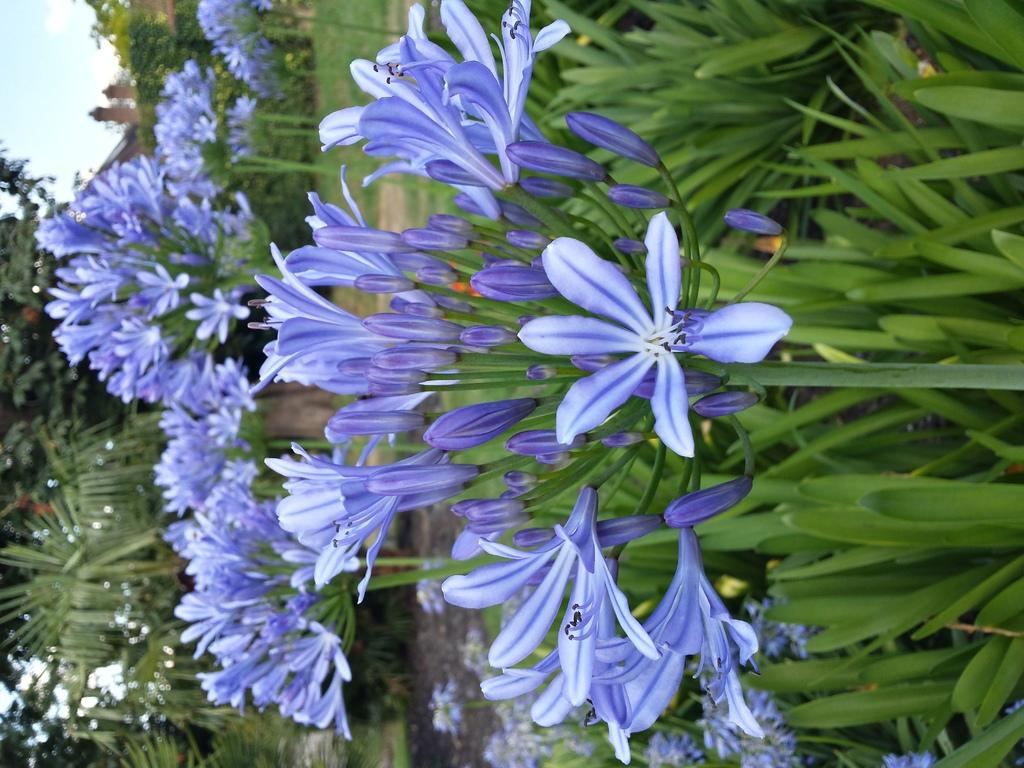What type of plants are in the middle of the image? There are flower plants in the middle of the image. What can be seen in the top left corner of the image? The sky is visible at the top left of the image. What type of vegetation is on the left side of the image? There are trees on the left side of the image. How many hands are visible in the image? There are no hands visible in the image. What type of needle is being used to sew the knot in the image? There is no needle or knot present in the image. 